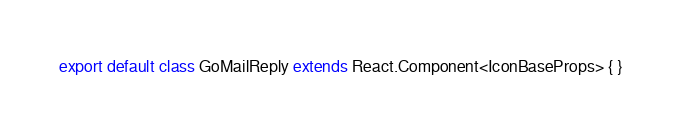Convert code to text. <code><loc_0><loc_0><loc_500><loc_500><_TypeScript_>export default class GoMailReply extends React.Component<IconBaseProps> { }
</code> 